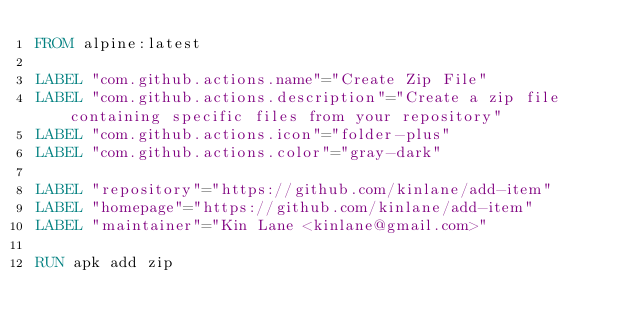<code> <loc_0><loc_0><loc_500><loc_500><_Dockerfile_>FROM alpine:latest

LABEL "com.github.actions.name"="Create Zip File"
LABEL "com.github.actions.description"="Create a zip file containing specific files from your repository"
LABEL "com.github.actions.icon"="folder-plus"
LABEL "com.github.actions.color"="gray-dark"

LABEL "repository"="https://github.com/kinlane/add-item"
LABEL "homepage"="https://github.com/kinlane/add-item"
LABEL "maintainer"="Kin Lane <kinlane@gmail.com>"

RUN apk add zip
</code> 